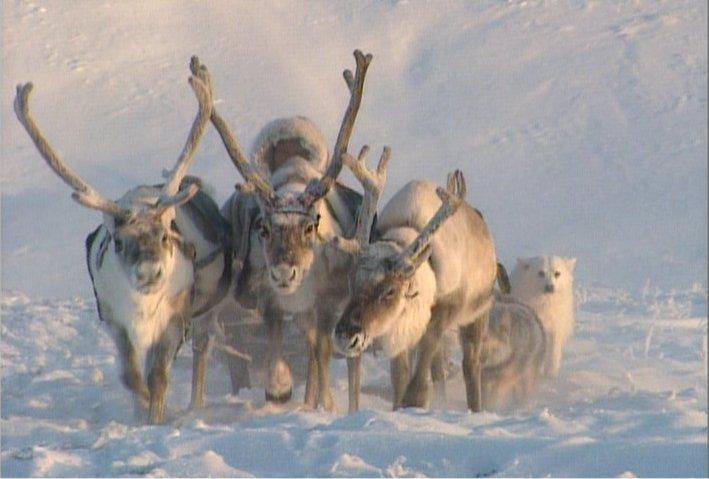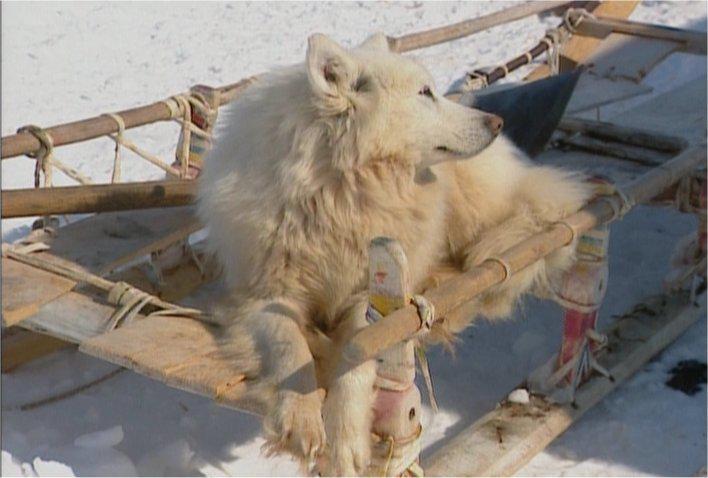The first image is the image on the left, the second image is the image on the right. For the images displayed, is the sentence "A white dog rounds up some sheep in one of the images." factually correct? Answer yes or no. No. The first image is the image on the left, the second image is the image on the right. Given the left and right images, does the statement "An image shows a white dog herding a group of sheep." hold true? Answer yes or no. No. 